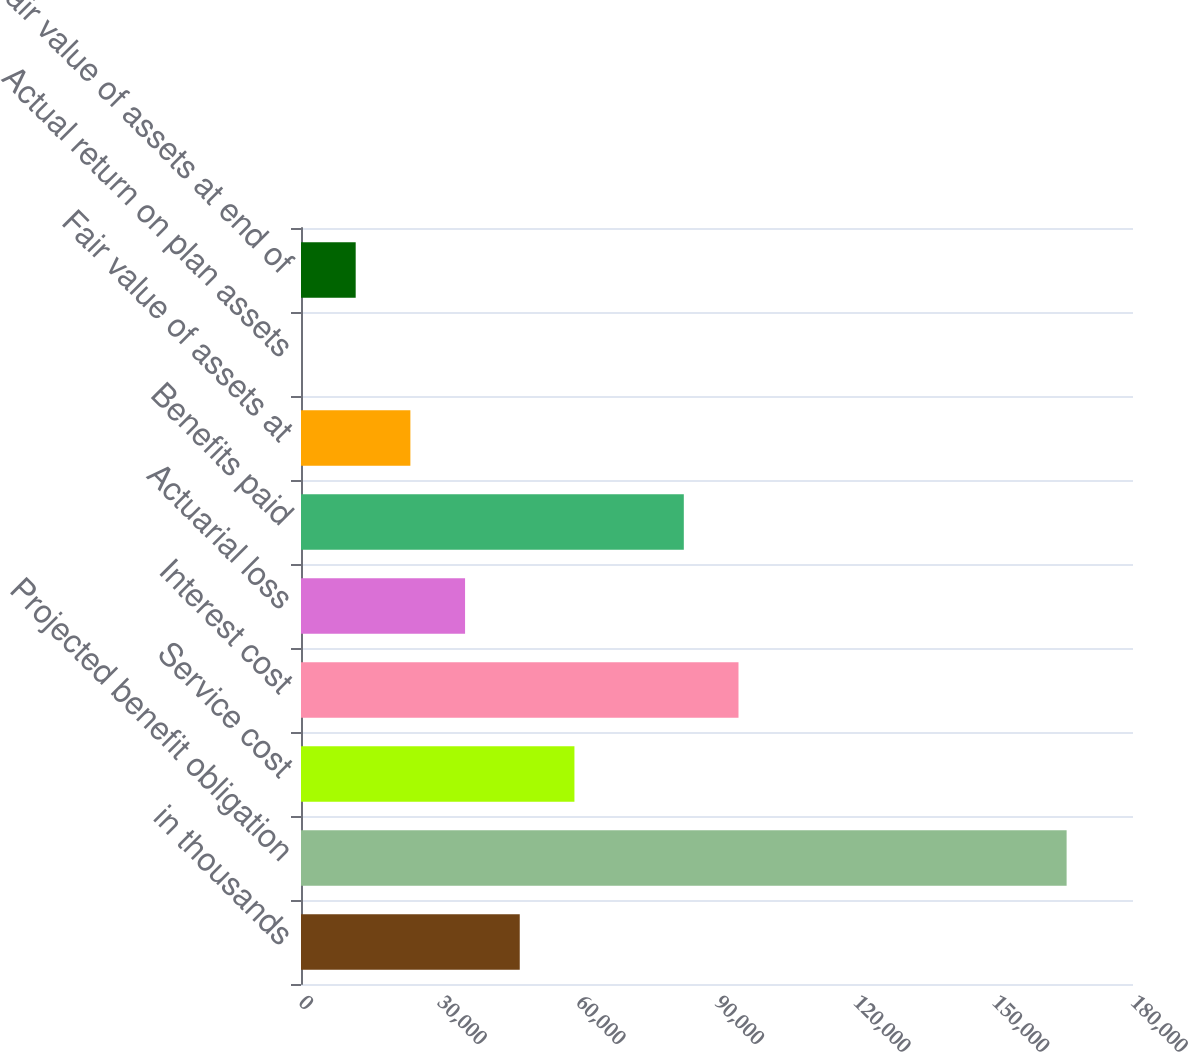<chart> <loc_0><loc_0><loc_500><loc_500><bar_chart><fcel>in thousands<fcel>Projected benefit obligation<fcel>Service cost<fcel>Interest cost<fcel>Actuarial loss<fcel>Benefits paid<fcel>Fair value of assets at<fcel>Actual return on plan assets<fcel>Fair value of assets at end of<nl><fcel>47325.7<fcel>165638<fcel>59156.9<fcel>94650.6<fcel>35494.5<fcel>82819.4<fcel>23663.3<fcel>0.84<fcel>11832.1<nl></chart> 